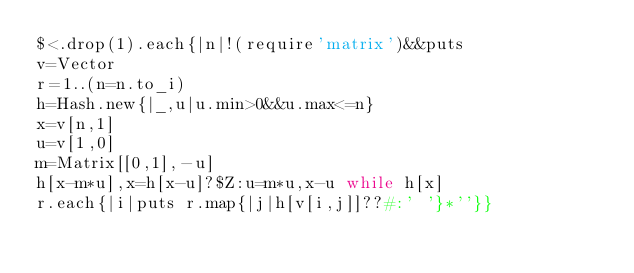<code> <loc_0><loc_0><loc_500><loc_500><_Ruby_>$<.drop(1).each{|n|!(require'matrix')&&puts
v=Vector
r=1..(n=n.to_i)
h=Hash.new{|_,u|u.min>0&&u.max<=n}
x=v[n,1]
u=v[1,0]
m=Matrix[[0,1],-u]
h[x-m*u],x=h[x-u]?$Z:u=m*u,x-u while h[x]
r.each{|i|puts r.map{|j|h[v[i,j]]??#:' '}*''}}
</code> 